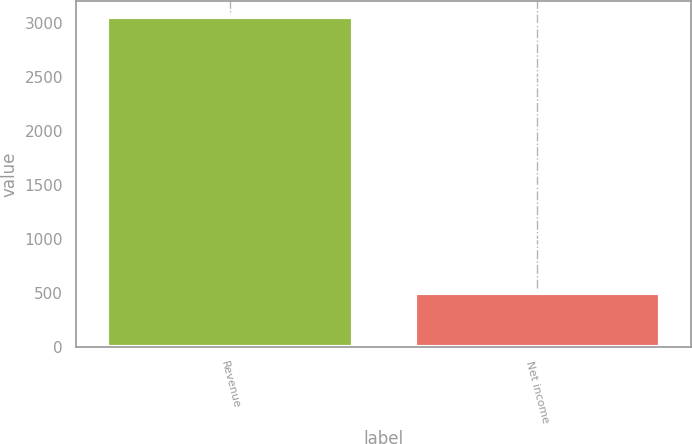Convert chart to OTSL. <chart><loc_0><loc_0><loc_500><loc_500><bar_chart><fcel>Revenue<fcel>Net income<nl><fcel>3056<fcel>501<nl></chart> 